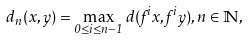<formula> <loc_0><loc_0><loc_500><loc_500>d _ { n } ( x , y ) = \max _ { 0 \leq i \leq n - 1 } d ( f ^ { i } x , f ^ { i } y ) , n \in \mathbb { N } ,</formula> 